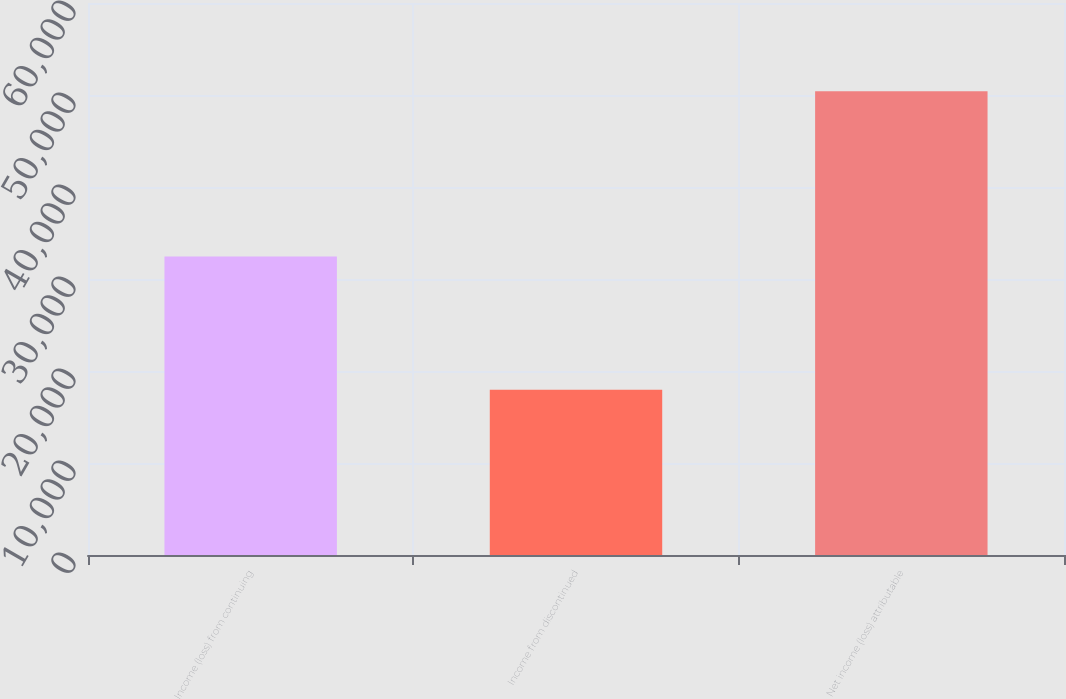Convert chart to OTSL. <chart><loc_0><loc_0><loc_500><loc_500><bar_chart><fcel>Income (loss) from continuing<fcel>Income from discontinued<fcel>Net income (loss) attributable<nl><fcel>32459<fcel>17949<fcel>50408<nl></chart> 